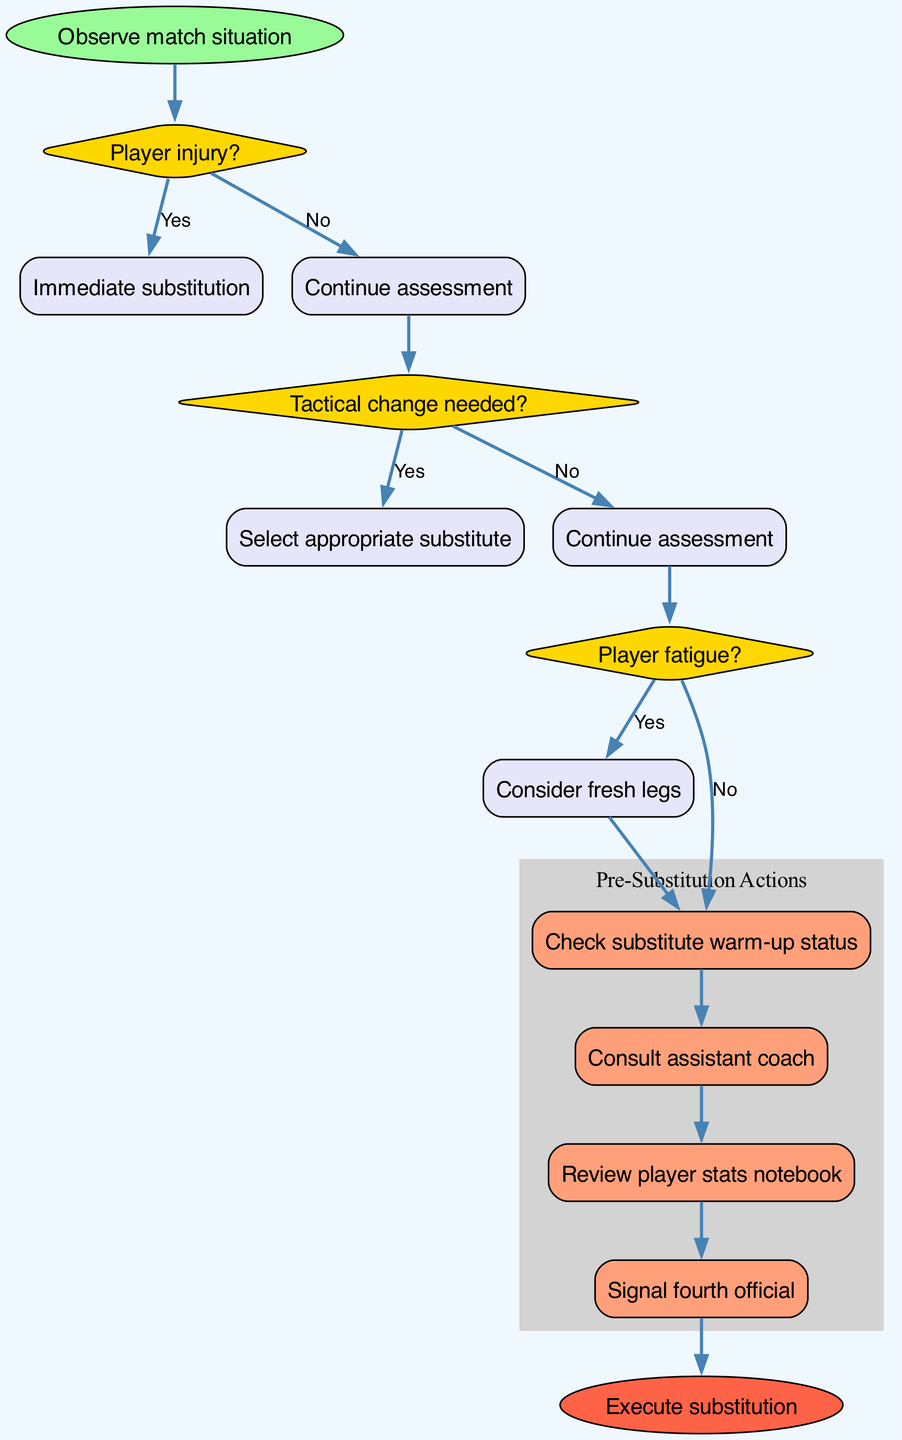What is the first step in the diagram? The first step in the diagram is "Observe match situation," which is the starting point of the flowchart that outlines the decision-making process for substituting players.
Answer: Observe match situation How many decision nodes are in the diagram? The diagram contains three decision nodes: "Player injury?", "Tactical change needed?", and "Player fatigue?". Each node represents a crucial decision-making point in the substitution process.
Answer: 3 What action follows the "Player fatigue?" decision if yes? If "Player fatigue?" is answered yes, the next action is "Consider fresh legs," indicating a focus on substituting fatigued players with fresher options.
Answer: Consider fresh legs What is the last action taken before executing the substitution? The last action taken before executing the substitution is "Signal fourth official," which is the final step in preparing for the substitution after all assessments have been made.
Answer: Signal fourth official What happens after the action "Check substitute warm-up status"? After checking the substitute warm-up status, the process allows for the next action, "Consult assistant coach," as part of the pre-substitution actions listed in the diagram.
Answer: Consult assistant coach What is the outcome if a "Tactical change needed?" is answered no? If "Tactical change needed?" is answered no, the assessment continues instead of moving to the action nodes, indicating ongoing evaluations without immediate substitutions.
Answer: Continue assessment How do the action nodes relate to the "Player fatigue?" decision? The action nodes are linked to the "Player fatigue?" decision; whether the decision is 'yes' or 'no', the flow eventually leads to checking substitute warm-up status before proceeding to execute the substitution.
Answer: They lead to actions regardless of yes/no 